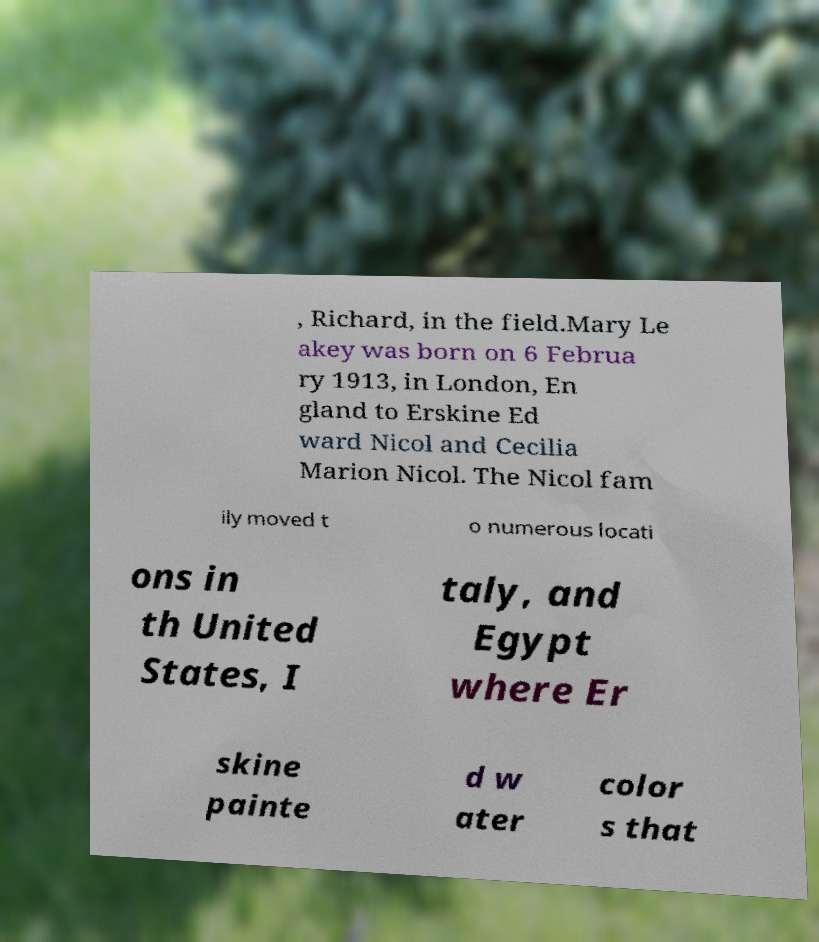I need the written content from this picture converted into text. Can you do that? , Richard, in the field.Mary Le akey was born on 6 Februa ry 1913, in London, En gland to Erskine Ed ward Nicol and Cecilia Marion Nicol. The Nicol fam ily moved t o numerous locati ons in th United States, I taly, and Egypt where Er skine painte d w ater color s that 